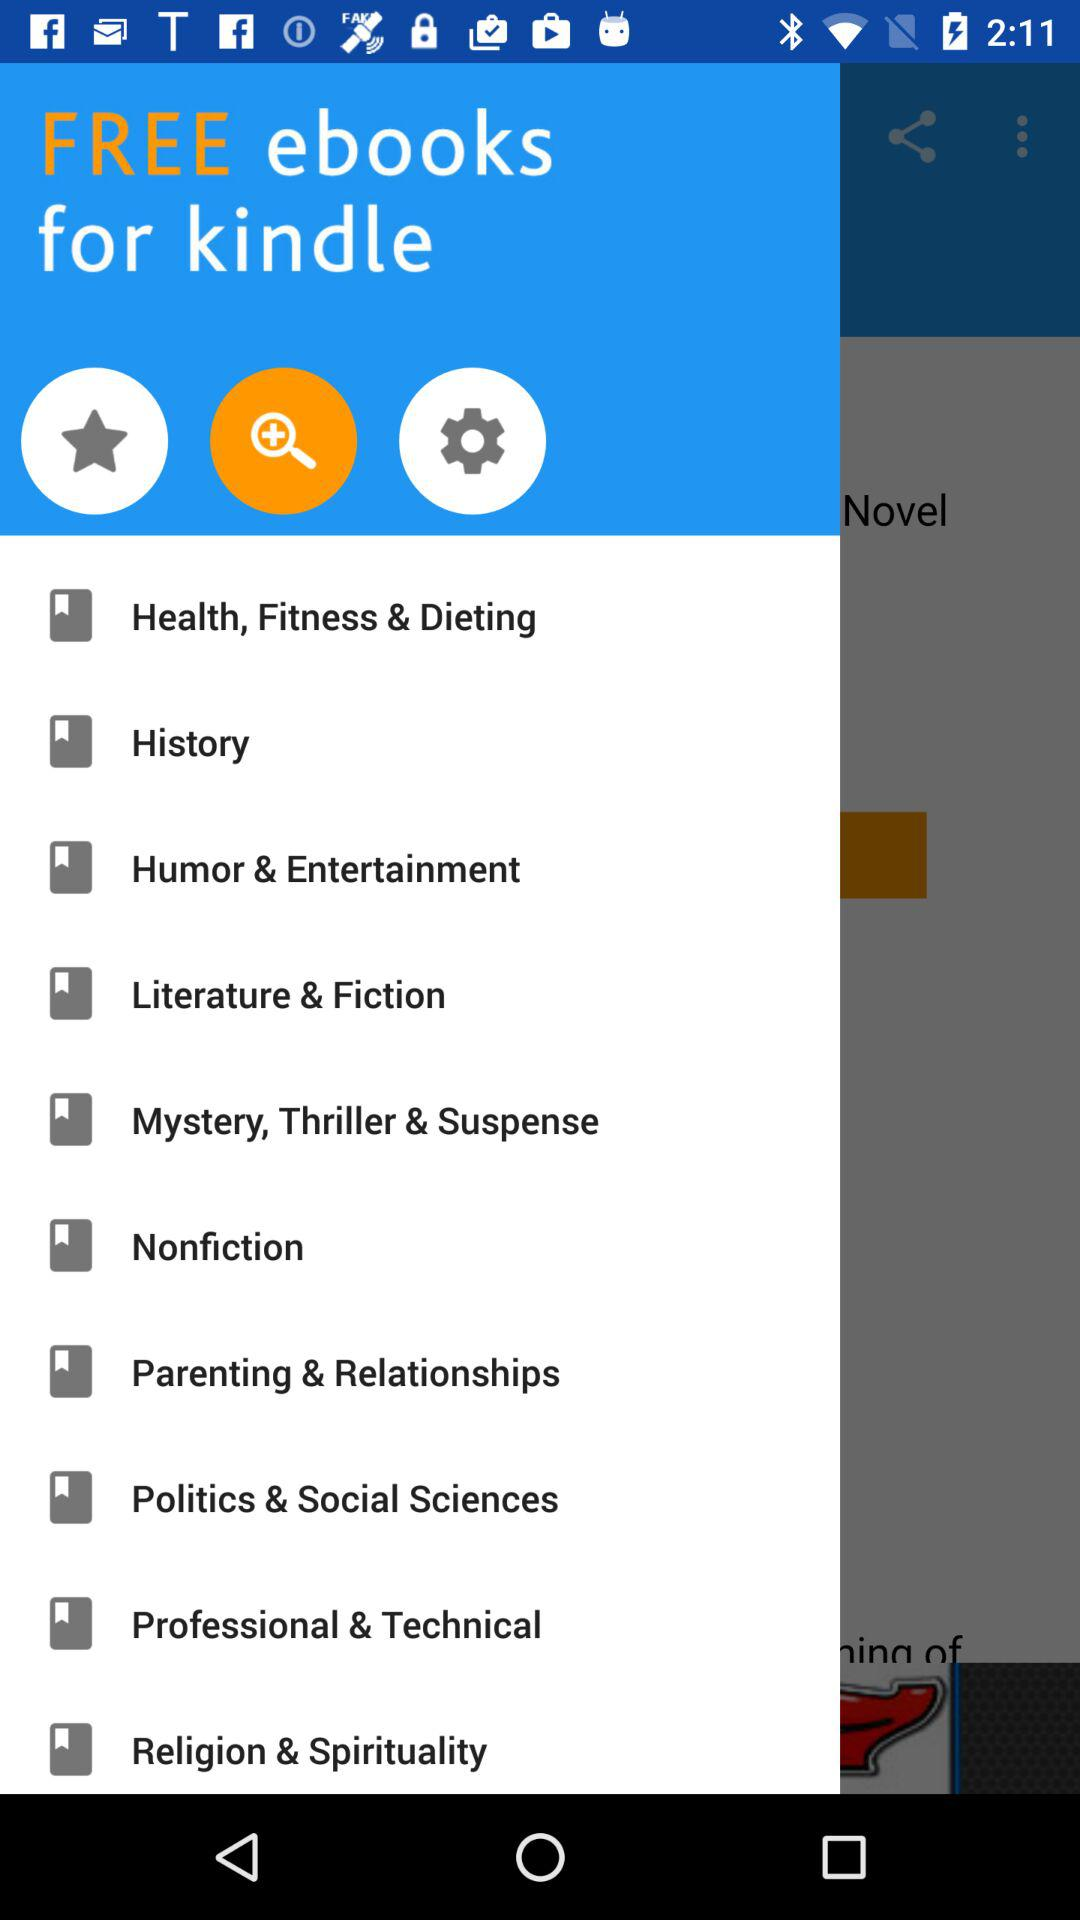How many categories are there?
Answer the question using a single word or phrase. 10 